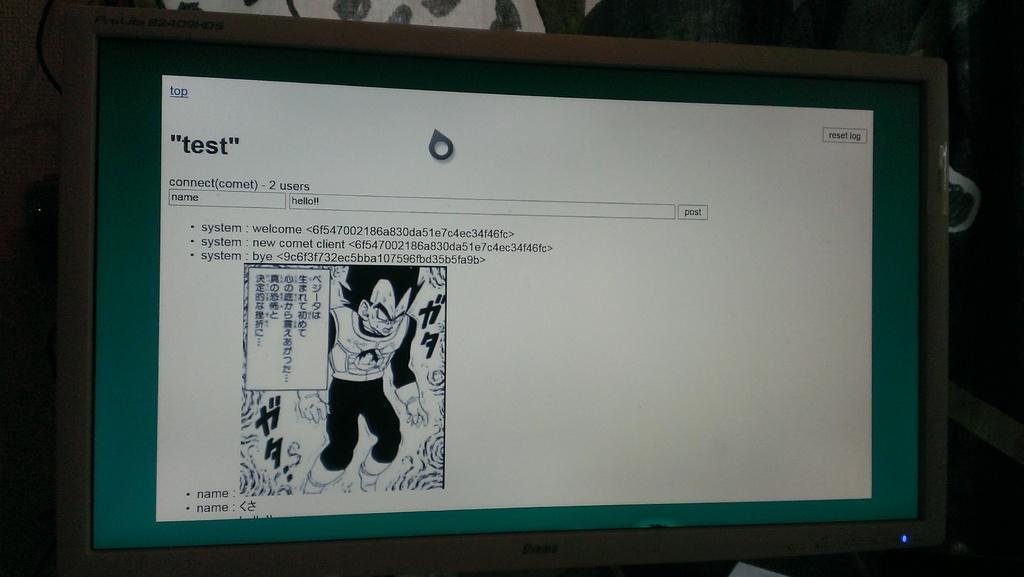<image>
Render a clear and concise summary of the photo. a computer monitor open to a page reading TEST 